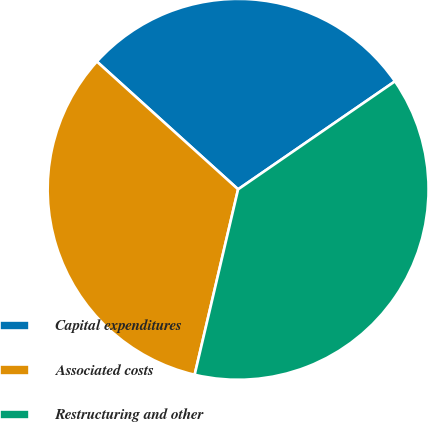Convert chart to OTSL. <chart><loc_0><loc_0><loc_500><loc_500><pie_chart><fcel>Capital expenditures<fcel>Associated costs<fcel>Restructuring and other<nl><fcel>28.7%<fcel>33.04%<fcel>38.26%<nl></chart> 